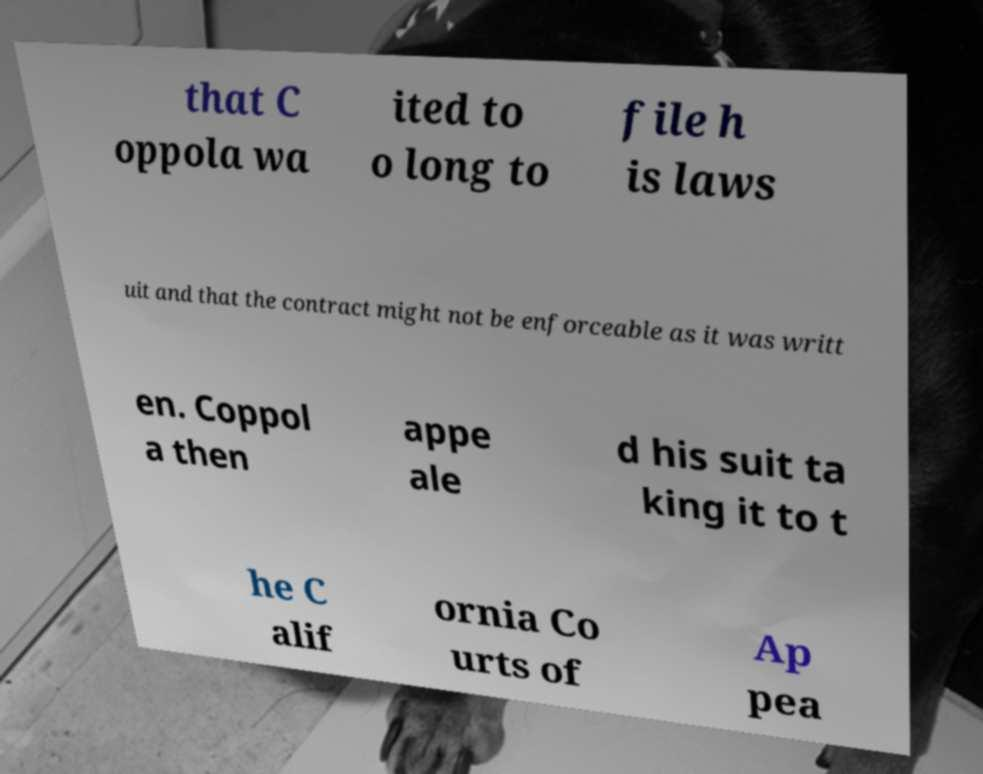Please identify and transcribe the text found in this image. that C oppola wa ited to o long to file h is laws uit and that the contract might not be enforceable as it was writt en. Coppol a then appe ale d his suit ta king it to t he C alif ornia Co urts of Ap pea 